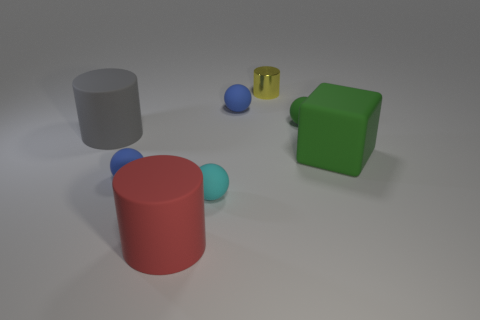Subtract 1 balls. How many balls are left? 3 Add 1 things. How many objects exist? 9 Subtract all cubes. How many objects are left? 7 Subtract all large gray rubber cylinders. Subtract all blue rubber spheres. How many objects are left? 5 Add 6 cubes. How many cubes are left? 7 Add 1 purple rubber objects. How many purple rubber objects exist? 1 Subtract 1 green spheres. How many objects are left? 7 